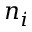<formula> <loc_0><loc_0><loc_500><loc_500>n _ { i }</formula> 